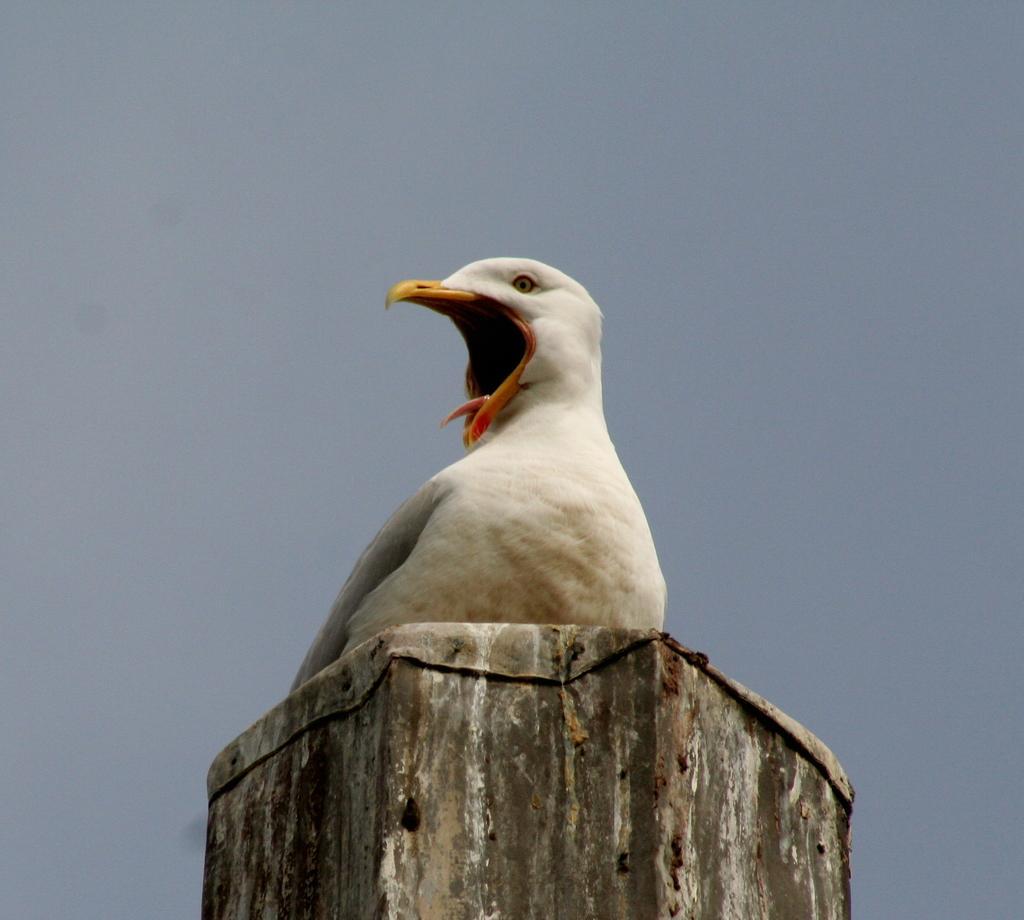Please provide a concise description of this image. In the foreground of this picture, there is a white bird on a wooden pole. In the background, we can see the sky. 